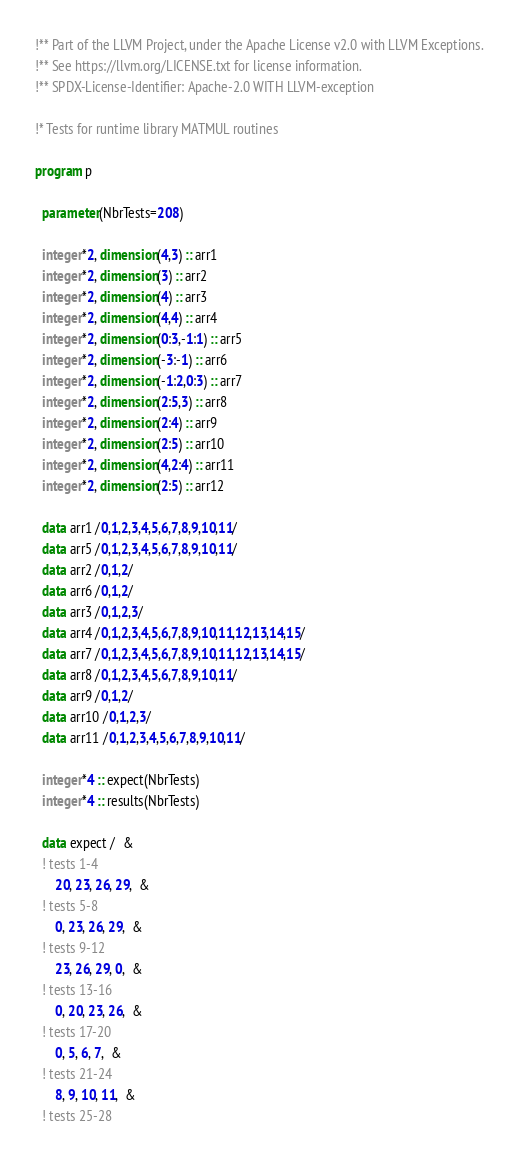Convert code to text. <code><loc_0><loc_0><loc_500><loc_500><_FORTRAN_>!** Part of the LLVM Project, under the Apache License v2.0 with LLVM Exceptions.
!** See https://llvm.org/LICENSE.txt for license information.
!** SPDX-License-Identifier: Apache-2.0 WITH LLVM-exception

!* Tests for runtime library MATMUL routines

program p

  parameter(NbrTests=208)

  integer*2, dimension(4,3) :: arr1
  integer*2, dimension(3) :: arr2
  integer*2, dimension(4) :: arr3
  integer*2, dimension(4,4) :: arr4
  integer*2, dimension(0:3,-1:1) :: arr5
  integer*2, dimension(-3:-1) :: arr6
  integer*2, dimension(-1:2,0:3) :: arr7
  integer*2, dimension(2:5,3) :: arr8
  integer*2, dimension(2:4) :: arr9
  integer*2, dimension(2:5) :: arr10
  integer*2, dimension(4,2:4) :: arr11
  integer*2, dimension(2:5) :: arr12

  data arr1 /0,1,2,3,4,5,6,7,8,9,10,11/
  data arr5 /0,1,2,3,4,5,6,7,8,9,10,11/
  data arr2 /0,1,2/
  data arr6 /0,1,2/
  data arr3 /0,1,2,3/
  data arr4 /0,1,2,3,4,5,6,7,8,9,10,11,12,13,14,15/
  data arr7 /0,1,2,3,4,5,6,7,8,9,10,11,12,13,14,15/
  data arr8 /0,1,2,3,4,5,6,7,8,9,10,11/
  data arr9 /0,1,2/
  data arr10 /0,1,2,3/
  data arr11 /0,1,2,3,4,5,6,7,8,9,10,11/

  integer*4 :: expect(NbrTests)
  integer*4 :: results(NbrTests)

  data expect /  &
  ! tests 1-4
      20, 23, 26, 29,  &
  ! tests 5-8
      0, 23, 26, 29,  &
  ! tests 9-12
      23, 26, 29, 0,  &
  ! tests 13-16
      0, 20, 23, 26,  &
  ! tests 17-20
      0, 5, 6, 7,  &
  ! tests 21-24
      8, 9, 10, 11,  &
  ! tests 25-28</code> 